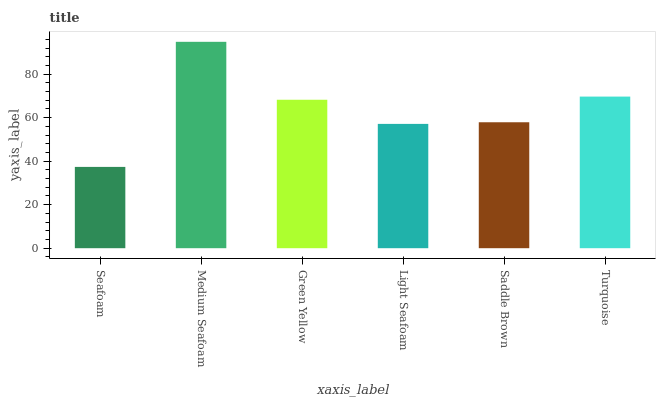Is Seafoam the minimum?
Answer yes or no. Yes. Is Medium Seafoam the maximum?
Answer yes or no. Yes. Is Green Yellow the minimum?
Answer yes or no. No. Is Green Yellow the maximum?
Answer yes or no. No. Is Medium Seafoam greater than Green Yellow?
Answer yes or no. Yes. Is Green Yellow less than Medium Seafoam?
Answer yes or no. Yes. Is Green Yellow greater than Medium Seafoam?
Answer yes or no. No. Is Medium Seafoam less than Green Yellow?
Answer yes or no. No. Is Green Yellow the high median?
Answer yes or no. Yes. Is Saddle Brown the low median?
Answer yes or no. Yes. Is Light Seafoam the high median?
Answer yes or no. No. Is Light Seafoam the low median?
Answer yes or no. No. 